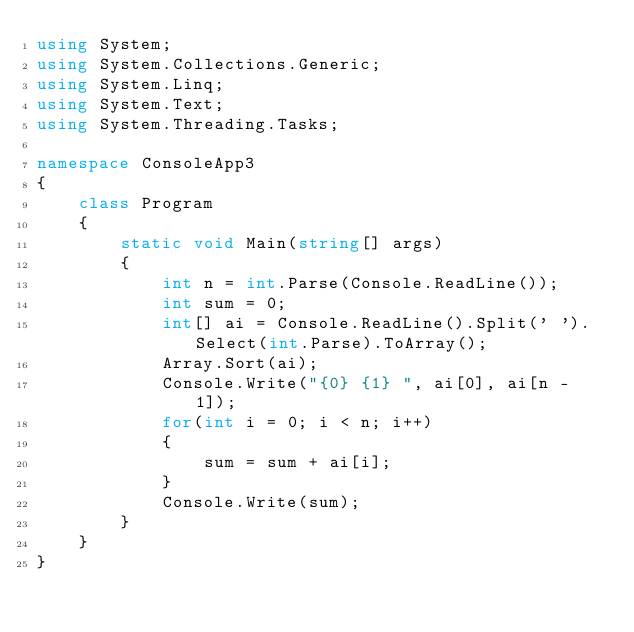<code> <loc_0><loc_0><loc_500><loc_500><_C#_>using System;
using System.Collections.Generic;
using System.Linq;
using System.Text;
using System.Threading.Tasks;

namespace ConsoleApp3
{
    class Program
    {
        static void Main(string[] args)
        {
            int n = int.Parse(Console.ReadLine());
            int sum = 0;
            int[] ai = Console.ReadLine().Split(' ').Select(int.Parse).ToArray();
            Array.Sort(ai);
            Console.Write("{0} {1} ", ai[0], ai[n - 1]);
            for(int i = 0; i < n; i++)
            {
                sum = sum + ai[i];
            }
            Console.Write(sum);
        }
    }
}
</code> 